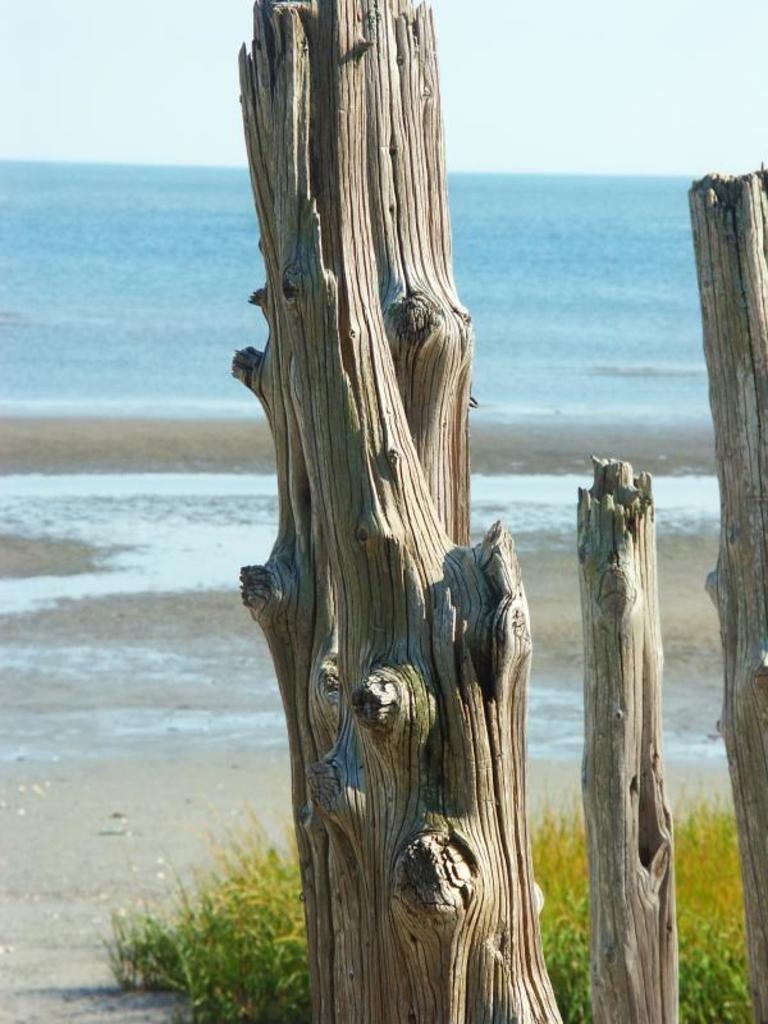What type of objects can be seen in the image? There are trunks in the image. What type of natural environment is depicted in the image? There is grass, sand, and water in the image. What can be seen in the background of the image? The sky is visible in the background of the image. What type of vegetable is growing in the prison depicted in the image? There is no prison or vegetable present in the image. The image features trunks, grass, sand, water, and a visible sky. 